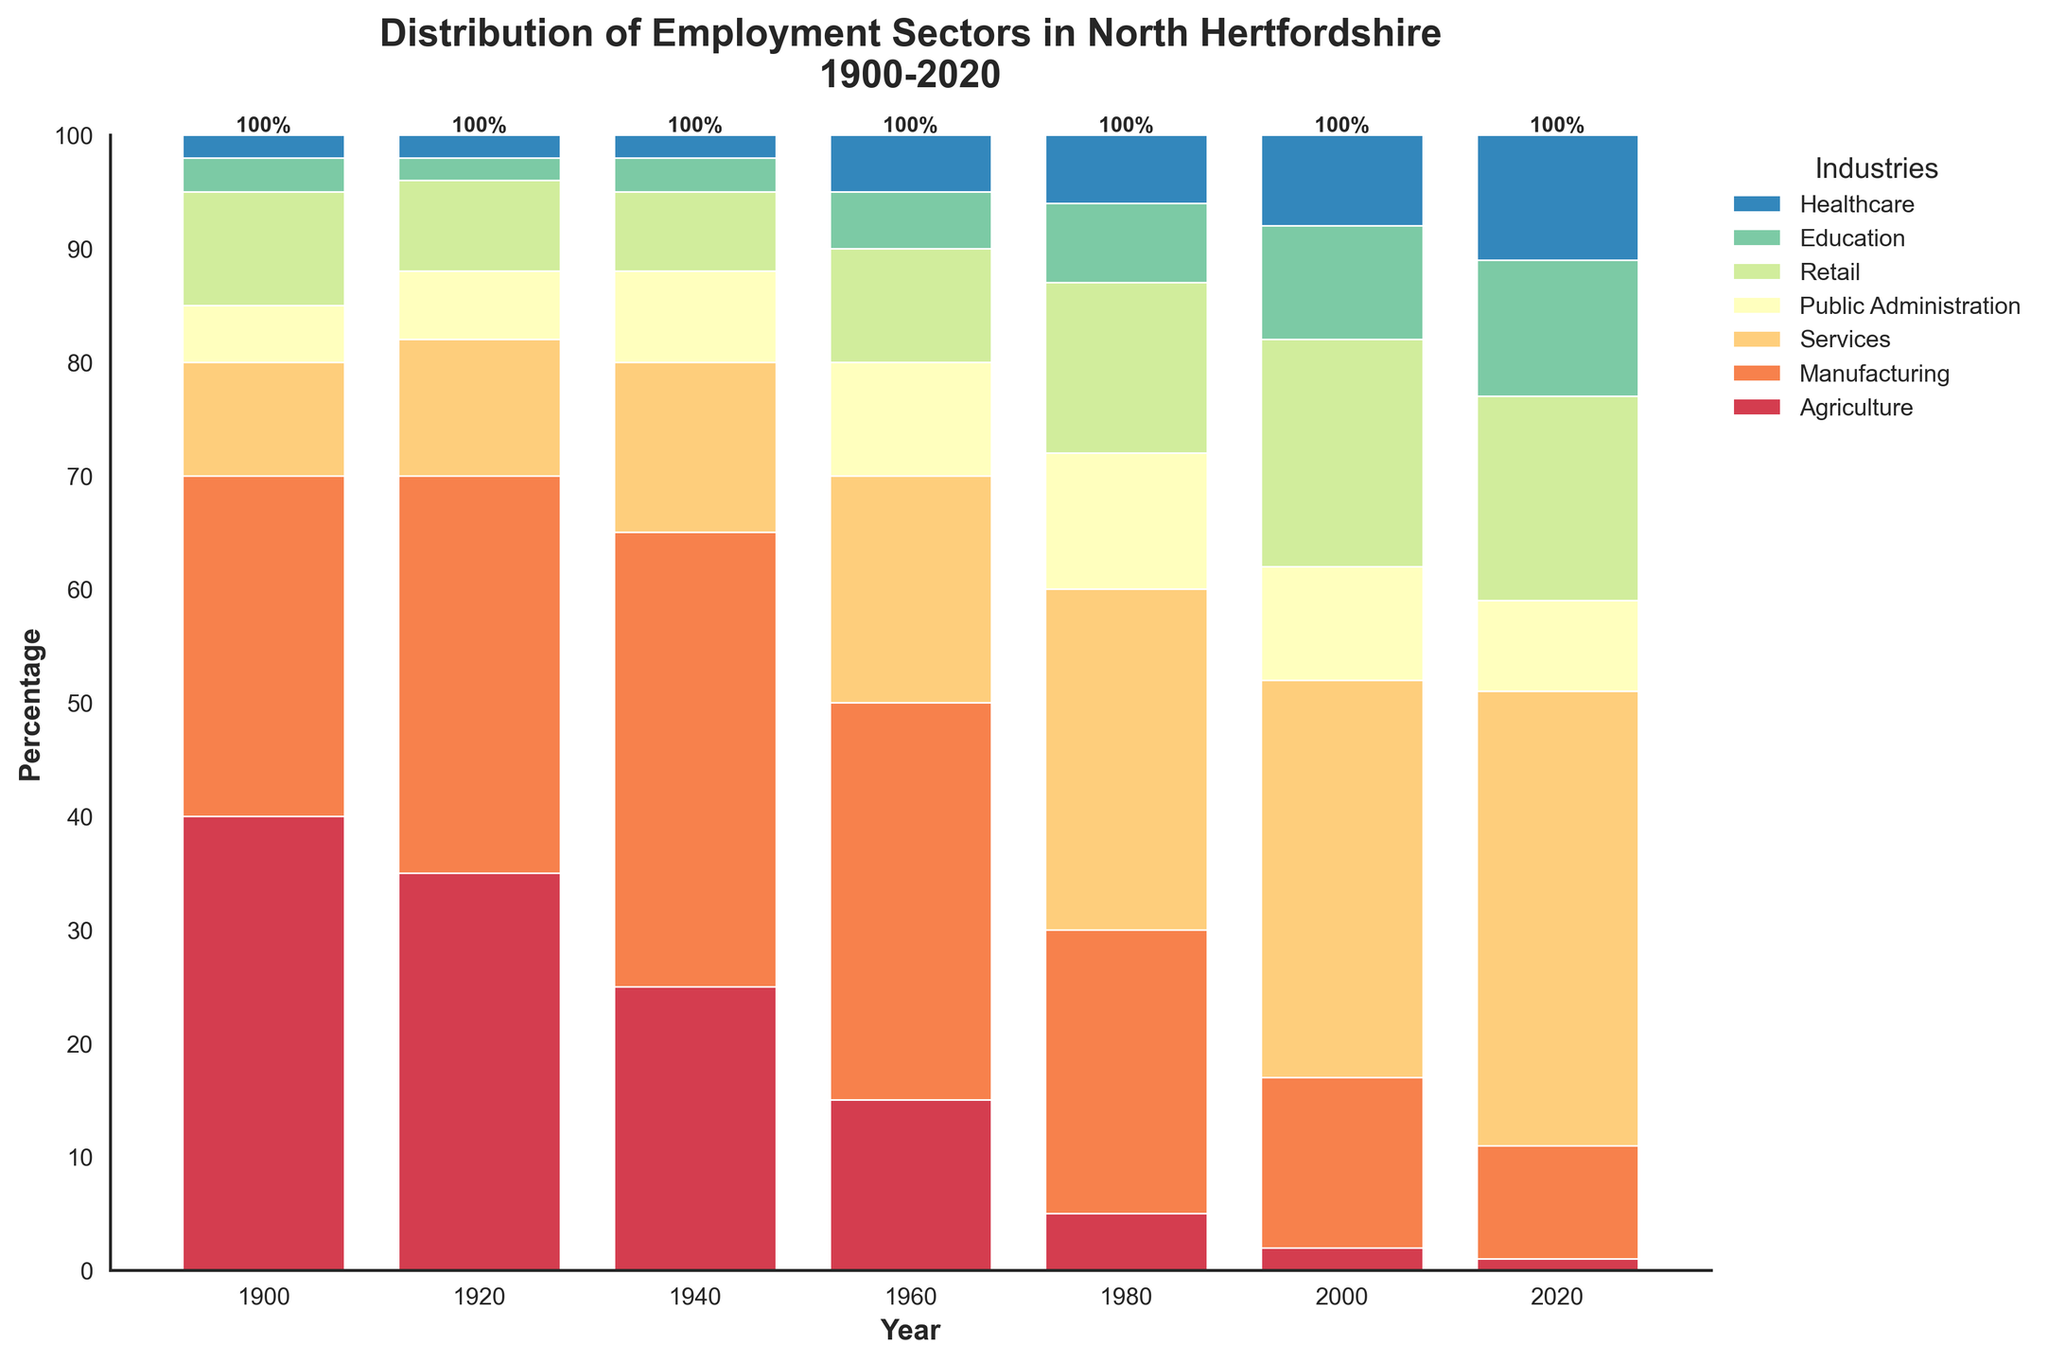Which employment sector had the highest percentage in 1940? Look at the bar corresponding to 1940 and identify the tallest segment. The tallest segment in 1940 belongs to Manufacturing.
Answer: Manufacturing How did the percentage of Agriculture employment change from 1900 to 2020? Compare the height of the Agriculture segment in 1900 and 2020. In 1900, Agriculture was at 40%, and in 2020, it was at 1%, indicating a decrease of 39 percentage points.
Answer: Decreased by 39 percentage points Which sector showed the most significant growth from 1900 to 2020? Compare the heights of all sectors in 1900 and 2020. Healthcare grew from 2% in 1900 to 11% in 2020, an increase of 9 percentage points, which is the most significant growth.
Answer: Healthcare In which year did Services first surpass Manufacturing in terms of employment percentage? Compare the height of the Services and Manufacturing segments for each year. Services first surpassed Manufacturing in 2000, where Services were at 35% and Manufacturing at 15%.
Answer: 2000 What is the total percentage of employment in Services, Retail, and Healthcare in 2020? Add the percentages of Services, Retail, and Healthcare for the year 2020. (40 + 18 + 11) = 69%.
Answer: 69% How does the employment percentage in Public Administration change from 1960 to 1980? Look at the heights of the Public Administration segment in 1960 and 1980. In 1960, it was 10%, and in 1980, it was 12%, indicating an increase of 2 percentage points.
Answer: Increased by 2 percentage points Which year shows the highest percentage of employment in Retail? Identify the tallest Retail segment on the chart. The tallest Retail segment is in 2000 at 20%.
Answer: 2000 Which sector had a consistent decline in its employment percentage from 1900 to 2020? Observe the trend of each sector over the years. Agriculture consistently declined from 40% in 1900 to 1% in 2020.
Answer: Agriculture How did the proportion of Manufacturing change from 1940 to 2000? Compare the height of the Manufacturing segments in 1940 and 2000. In 1940, Manufacturing was at 40%, and in 2000, it was at 15%, showing a decrease of 25 percentage points.
Answer: Decreased by 25 percentage points In which sector did employment double from 1960 to 2020? Identify segments that doubled in height from 1960 to 2020. Education went from 5% in 1960 to 12% in 2020.
Answer: Education 